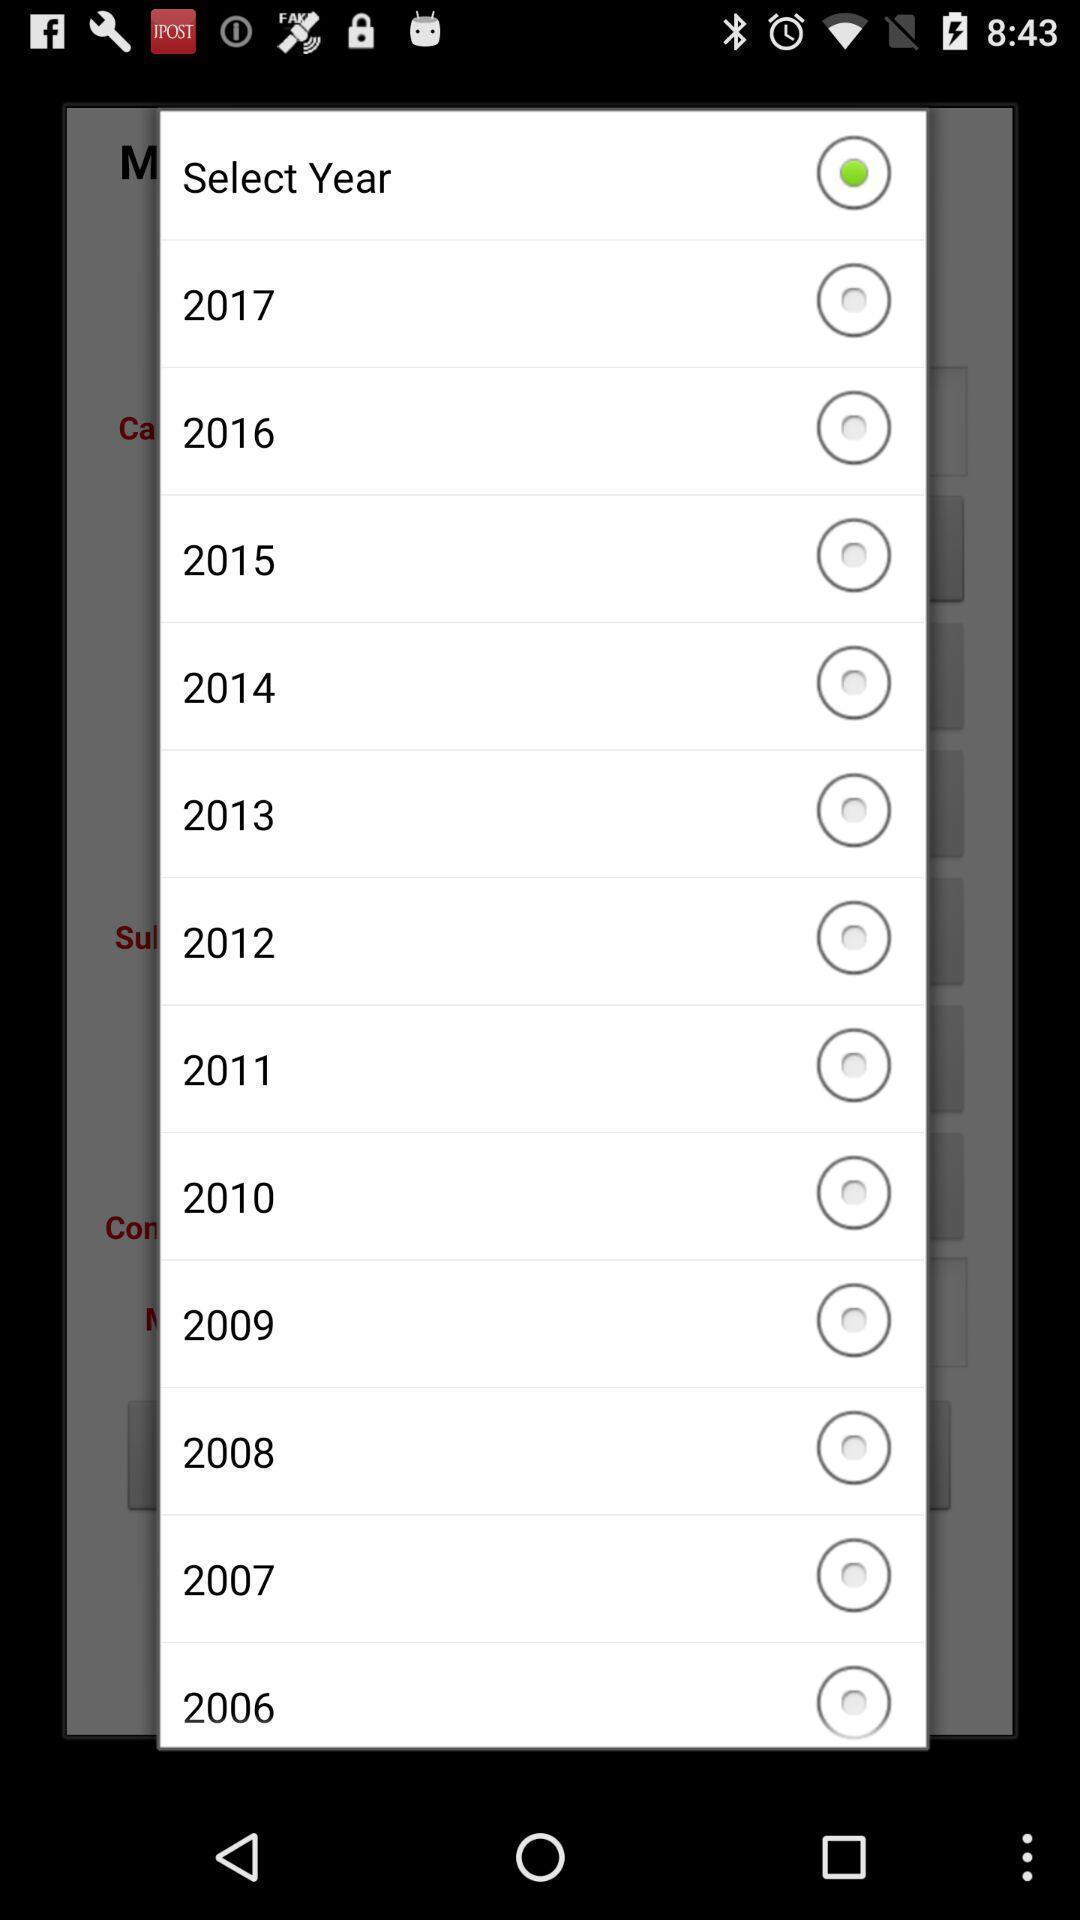Give me a narrative description of this picture. Popup showing years to select. 